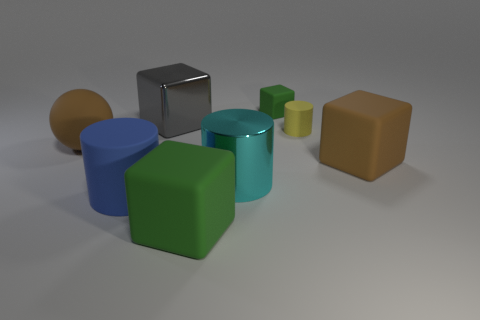Subtract all big green rubber blocks. How many blocks are left? 3 Subtract all gray blocks. How many blocks are left? 3 Add 2 yellow rubber cylinders. How many objects exist? 10 Subtract all purple blocks. Subtract all green cylinders. How many blocks are left? 4 Subtract all balls. How many objects are left? 7 Subtract all matte cylinders. Subtract all large cyan cylinders. How many objects are left? 5 Add 1 big blocks. How many big blocks are left? 4 Add 7 small green rubber objects. How many small green rubber objects exist? 8 Subtract 0 yellow blocks. How many objects are left? 8 